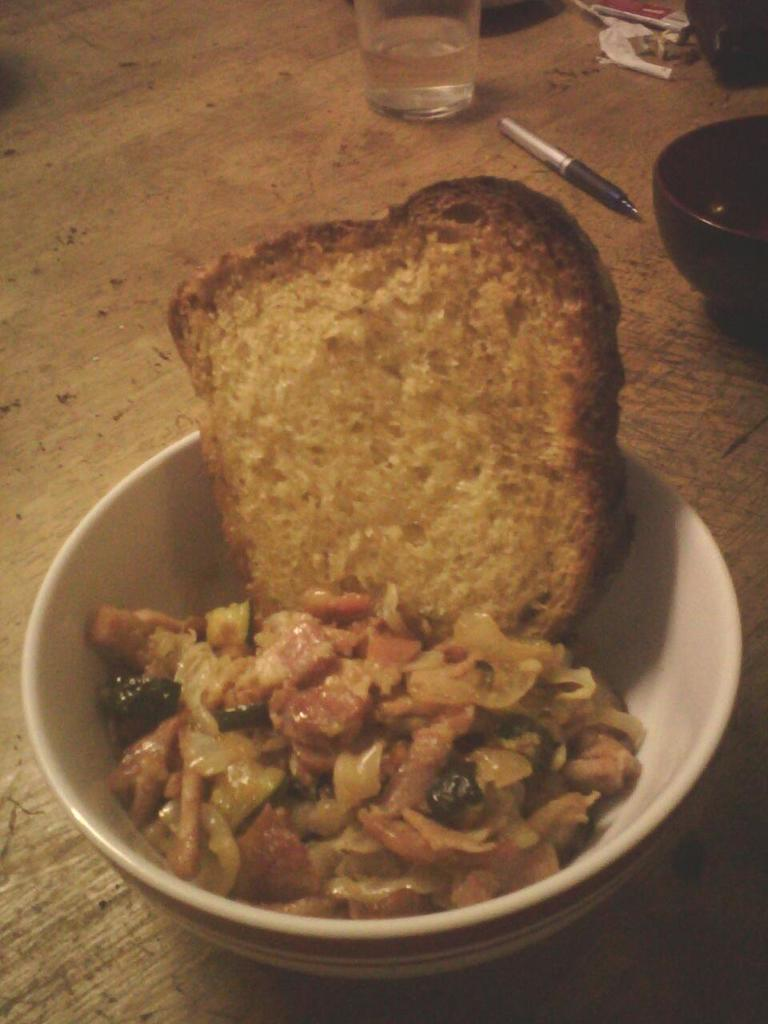What color is the bowl in the image? The bowl in the image is white. What is inside the bowl? The bowl contains food items. Can you describe any other objects visible in the background? There is a glass in the background of the image, and there are other objects on a wooden surface. Is there a beggar asking for payment in the image? No, there is no beggar or any indication of payment in the image. What type of measuring device is used to measure the food items in the image? There is no measuring device visible in the image. 